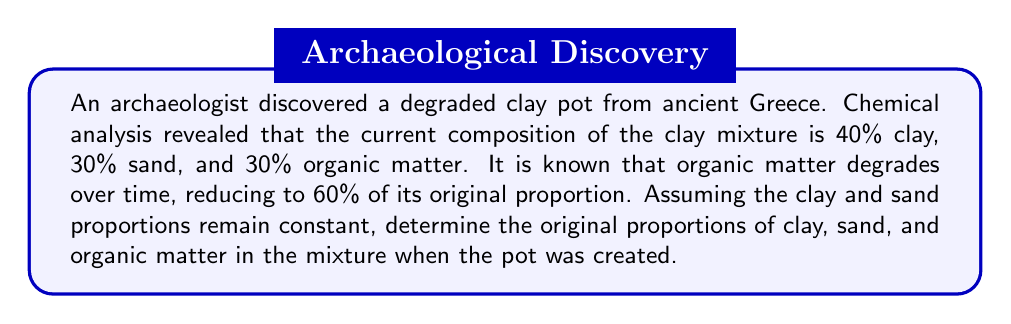Solve this math problem. Let's approach this step-by-step:

1) Let $x$ be the original proportion of organic matter in the mixture.

2) We know that the current organic matter is 60% of the original, so:
   $0.30 = 0.6x$

3) Solving for $x$:
   $x = 0.30 / 0.6 = 0.50$ or 50%

4) Now, we know that the original mixture contained 50% organic matter. Let's call the original proportions of clay and sand $y$ and $z$ respectively.

5) We know that the ratio of clay to sand remains constant. In the current mixture, this ratio is 40:30 or 4:3. So:
   $y : z = 4 : 3$

6) We can express this as an equation:
   $y = \frac{4}{3}z$

7) We also know that the sum of all proportions must equal 1:
   $y + z + 0.50 = 1$

8) Substituting the expression for $y$ from step 6:
   $\frac{4}{3}z + z + 0.50 = 1$

9) Simplifying:
   $\frac{7}{3}z + 0.50 = 1$
   $\frac{7}{3}z = 0.50$
   $z = 0.50 * \frac{3}{7} = \frac{3}{14} \approx 0.2143$

10) Now we can find $y$:
    $y = \frac{4}{3}z = \frac{4}{3} * \frac{3}{14} = \frac{2}{7} \approx 0.2857$

Therefore, the original proportions were approximately:
Clay (y): 28.57%
Sand (z): 21.43%
Organic matter (x): 50%
Answer: Clay: 28.57%, Sand: 21.43%, Organic matter: 50% 